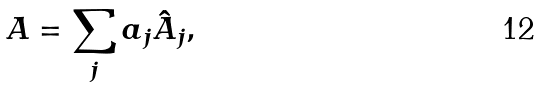<formula> <loc_0><loc_0><loc_500><loc_500>A = \sum _ { j } a _ { j } \hat { A } _ { j } ,</formula> 